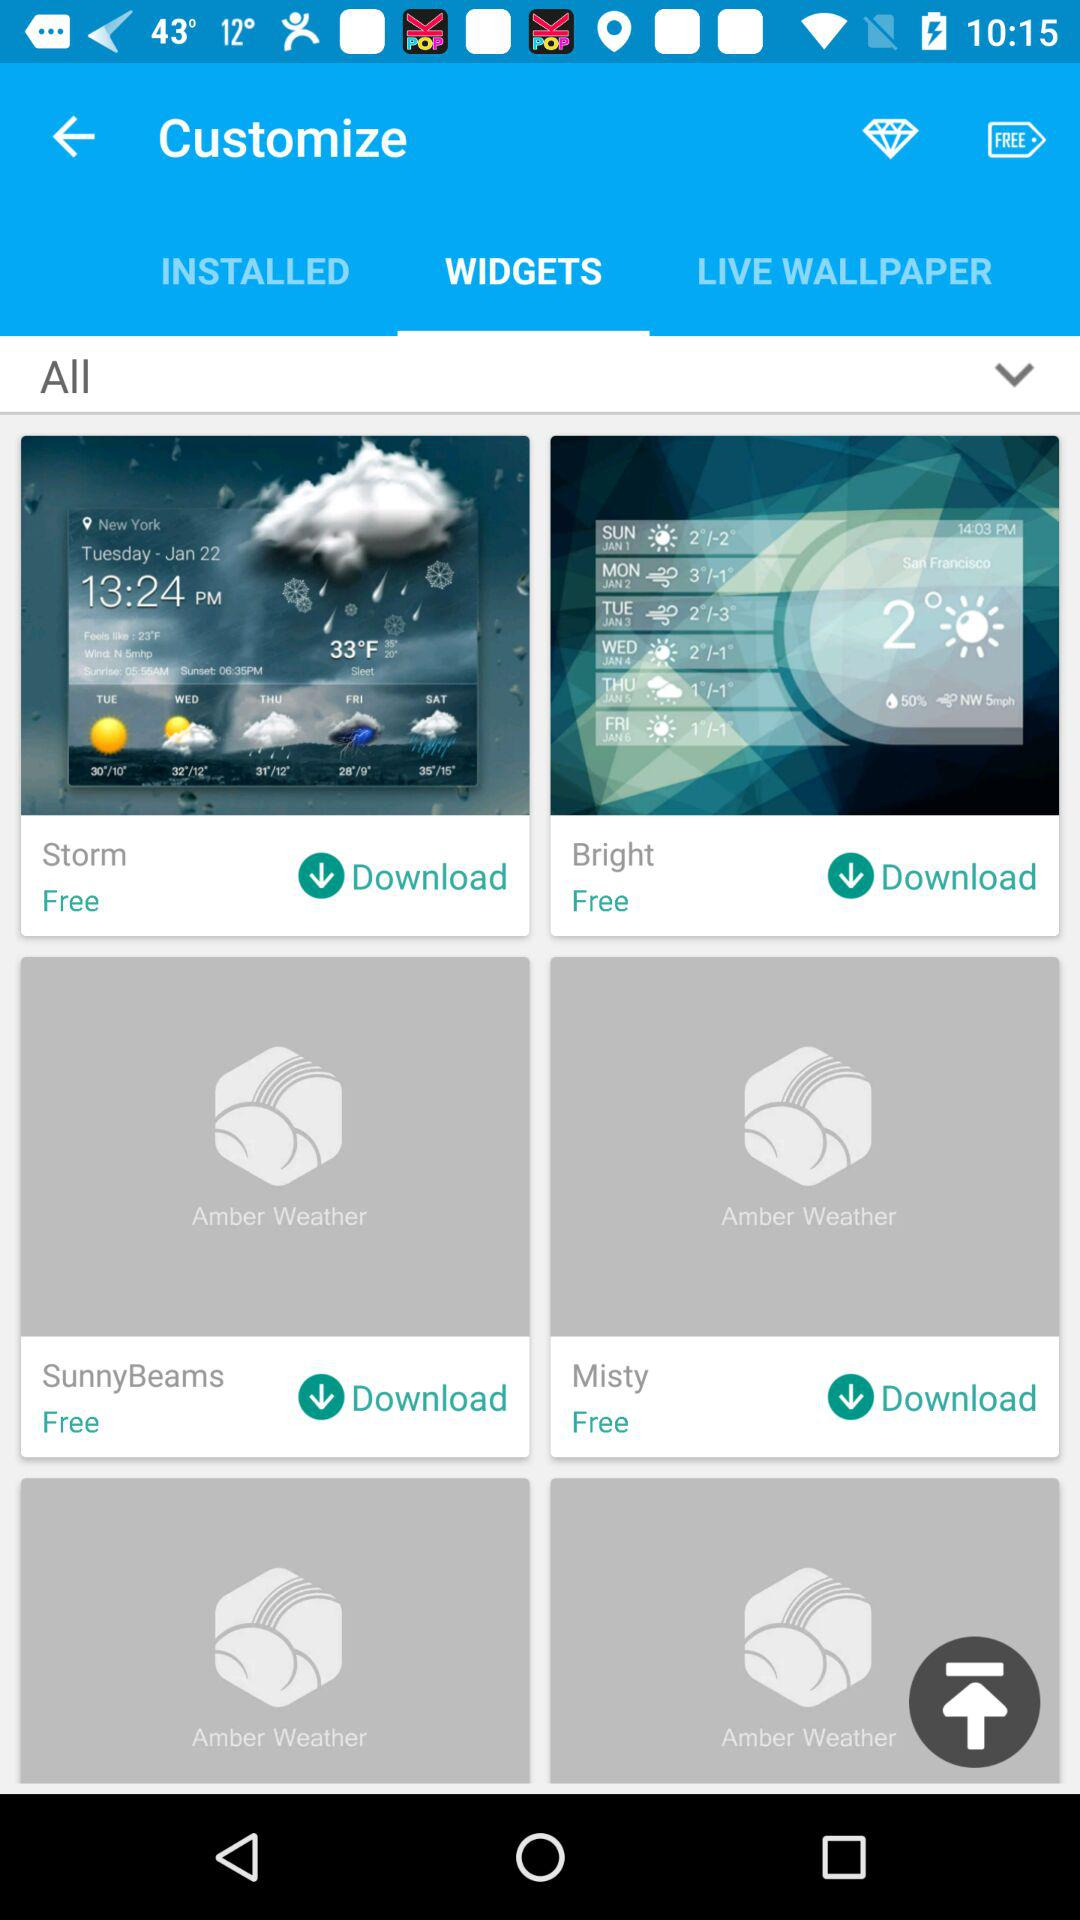What is the selected tab? The selected tab is "WIDGETS". 